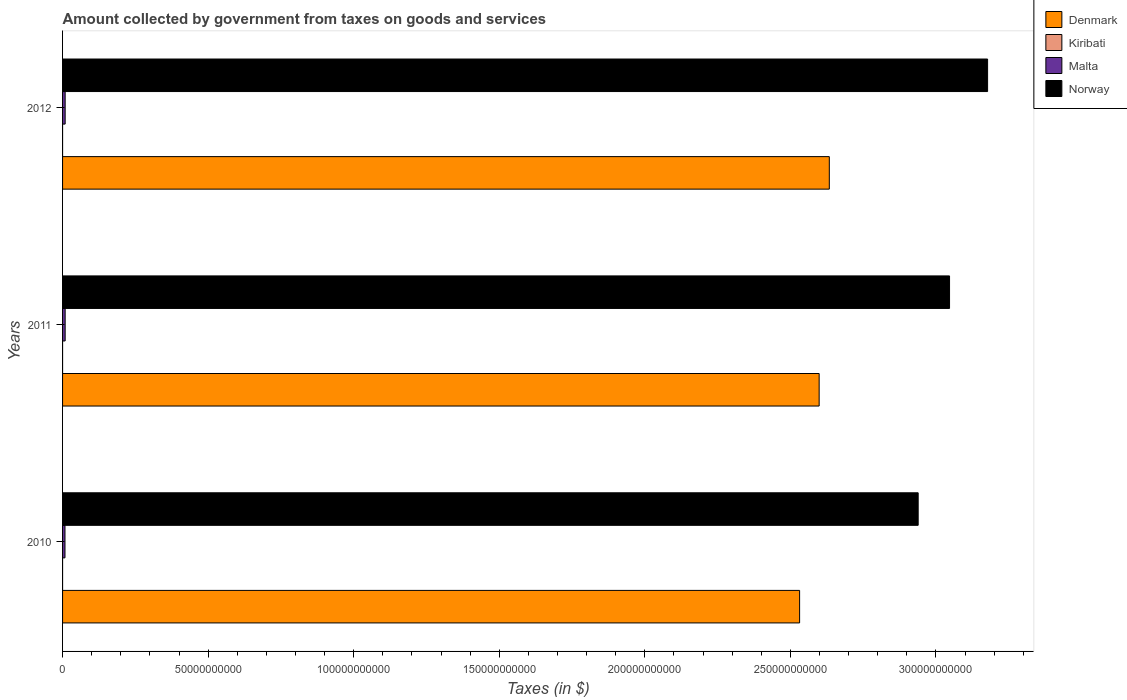Are the number of bars per tick equal to the number of legend labels?
Offer a terse response. Yes. Are the number of bars on each tick of the Y-axis equal?
Provide a succinct answer. Yes. How many bars are there on the 1st tick from the bottom?
Your answer should be very brief. 4. What is the label of the 3rd group of bars from the top?
Keep it short and to the point. 2010. What is the amount collected by government from taxes on goods and services in Kiribati in 2012?
Offer a very short reply. 7.29e+04. Across all years, what is the maximum amount collected by government from taxes on goods and services in Denmark?
Ensure brevity in your answer.  2.63e+11. Across all years, what is the minimum amount collected by government from taxes on goods and services in Kiribati?
Your answer should be compact. 7.29e+04. What is the total amount collected by government from taxes on goods and services in Denmark in the graph?
Give a very brief answer. 7.76e+11. What is the difference between the amount collected by government from taxes on goods and services in Malta in 2010 and that in 2011?
Offer a very short reply. -6.32e+07. What is the difference between the amount collected by government from taxes on goods and services in Malta in 2011 and the amount collected by government from taxes on goods and services in Norway in 2012?
Provide a short and direct response. -3.17e+11. What is the average amount collected by government from taxes on goods and services in Denmark per year?
Keep it short and to the point. 2.59e+11. In the year 2010, what is the difference between the amount collected by government from taxes on goods and services in Denmark and amount collected by government from taxes on goods and services in Kiribati?
Your answer should be very brief. 2.53e+11. In how many years, is the amount collected by government from taxes on goods and services in Kiribati greater than 260000000000 $?
Keep it short and to the point. 0. What is the ratio of the amount collected by government from taxes on goods and services in Malta in 2011 to that in 2012?
Your response must be concise. 1. Is the difference between the amount collected by government from taxes on goods and services in Denmark in 2011 and 2012 greater than the difference between the amount collected by government from taxes on goods and services in Kiribati in 2011 and 2012?
Keep it short and to the point. No. What is the difference between the highest and the second highest amount collected by government from taxes on goods and services in Kiribati?
Offer a very short reply. 1.47e+05. What is the difference between the highest and the lowest amount collected by government from taxes on goods and services in Malta?
Ensure brevity in your answer.  6.33e+07. Is it the case that in every year, the sum of the amount collected by government from taxes on goods and services in Denmark and amount collected by government from taxes on goods and services in Norway is greater than the sum of amount collected by government from taxes on goods and services in Kiribati and amount collected by government from taxes on goods and services in Malta?
Your answer should be very brief. Yes. What does the 2nd bar from the bottom in 2010 represents?
Provide a short and direct response. Kiribati. How many bars are there?
Offer a very short reply. 12. How many years are there in the graph?
Offer a very short reply. 3. What is the difference between two consecutive major ticks on the X-axis?
Provide a short and direct response. 5.00e+1. Are the values on the major ticks of X-axis written in scientific E-notation?
Offer a terse response. No. Does the graph contain any zero values?
Offer a very short reply. No. Does the graph contain grids?
Keep it short and to the point. No. Where does the legend appear in the graph?
Keep it short and to the point. Top right. What is the title of the graph?
Your answer should be very brief. Amount collected by government from taxes on goods and services. Does "Burundi" appear as one of the legend labels in the graph?
Provide a succinct answer. No. What is the label or title of the X-axis?
Make the answer very short. Taxes (in $). What is the label or title of the Y-axis?
Provide a short and direct response. Years. What is the Taxes (in $) in Denmark in 2010?
Keep it short and to the point. 2.53e+11. What is the Taxes (in $) in Kiribati in 2010?
Ensure brevity in your answer.  2.22e+05. What is the Taxes (in $) in Malta in 2010?
Your answer should be very brief. 8.29e+08. What is the Taxes (in $) in Norway in 2010?
Your answer should be very brief. 2.94e+11. What is the Taxes (in $) of Denmark in 2011?
Keep it short and to the point. 2.60e+11. What is the Taxes (in $) of Kiribati in 2011?
Make the answer very short. 7.46e+04. What is the Taxes (in $) of Malta in 2011?
Provide a short and direct response. 8.92e+08. What is the Taxes (in $) in Norway in 2011?
Your answer should be very brief. 3.05e+11. What is the Taxes (in $) of Denmark in 2012?
Your answer should be very brief. 2.63e+11. What is the Taxes (in $) in Kiribati in 2012?
Ensure brevity in your answer.  7.29e+04. What is the Taxes (in $) of Malta in 2012?
Your answer should be very brief. 8.92e+08. What is the Taxes (in $) in Norway in 2012?
Offer a very short reply. 3.18e+11. Across all years, what is the maximum Taxes (in $) in Denmark?
Give a very brief answer. 2.63e+11. Across all years, what is the maximum Taxes (in $) of Kiribati?
Keep it short and to the point. 2.22e+05. Across all years, what is the maximum Taxes (in $) in Malta?
Make the answer very short. 8.92e+08. Across all years, what is the maximum Taxes (in $) of Norway?
Your response must be concise. 3.18e+11. Across all years, what is the minimum Taxes (in $) of Denmark?
Your response must be concise. 2.53e+11. Across all years, what is the minimum Taxes (in $) in Kiribati?
Your response must be concise. 7.29e+04. Across all years, what is the minimum Taxes (in $) of Malta?
Give a very brief answer. 8.29e+08. Across all years, what is the minimum Taxes (in $) of Norway?
Make the answer very short. 2.94e+11. What is the total Taxes (in $) in Denmark in the graph?
Your response must be concise. 7.76e+11. What is the total Taxes (in $) in Kiribati in the graph?
Ensure brevity in your answer.  3.69e+05. What is the total Taxes (in $) of Malta in the graph?
Provide a succinct answer. 2.61e+09. What is the total Taxes (in $) in Norway in the graph?
Give a very brief answer. 9.16e+11. What is the difference between the Taxes (in $) in Denmark in 2010 and that in 2011?
Provide a succinct answer. -6.71e+09. What is the difference between the Taxes (in $) of Kiribati in 2010 and that in 2011?
Provide a short and direct response. 1.47e+05. What is the difference between the Taxes (in $) in Malta in 2010 and that in 2011?
Offer a terse response. -6.32e+07. What is the difference between the Taxes (in $) in Norway in 2010 and that in 2011?
Offer a terse response. -1.08e+1. What is the difference between the Taxes (in $) of Denmark in 2010 and that in 2012?
Your response must be concise. -1.02e+1. What is the difference between the Taxes (in $) in Kiribati in 2010 and that in 2012?
Your answer should be compact. 1.49e+05. What is the difference between the Taxes (in $) in Malta in 2010 and that in 2012?
Make the answer very short. -6.33e+07. What is the difference between the Taxes (in $) in Norway in 2010 and that in 2012?
Provide a short and direct response. -2.38e+1. What is the difference between the Taxes (in $) of Denmark in 2011 and that in 2012?
Ensure brevity in your answer.  -3.49e+09. What is the difference between the Taxes (in $) of Kiribati in 2011 and that in 2012?
Provide a short and direct response. 1687.54. What is the difference between the Taxes (in $) of Malta in 2011 and that in 2012?
Provide a succinct answer. -1.06e+05. What is the difference between the Taxes (in $) in Norway in 2011 and that in 2012?
Keep it short and to the point. -1.31e+1. What is the difference between the Taxes (in $) in Denmark in 2010 and the Taxes (in $) in Kiribati in 2011?
Give a very brief answer. 2.53e+11. What is the difference between the Taxes (in $) in Denmark in 2010 and the Taxes (in $) in Malta in 2011?
Give a very brief answer. 2.52e+11. What is the difference between the Taxes (in $) in Denmark in 2010 and the Taxes (in $) in Norway in 2011?
Provide a short and direct response. -5.15e+1. What is the difference between the Taxes (in $) in Kiribati in 2010 and the Taxes (in $) in Malta in 2011?
Make the answer very short. -8.92e+08. What is the difference between the Taxes (in $) of Kiribati in 2010 and the Taxes (in $) of Norway in 2011?
Your answer should be compact. -3.05e+11. What is the difference between the Taxes (in $) of Malta in 2010 and the Taxes (in $) of Norway in 2011?
Your answer should be very brief. -3.04e+11. What is the difference between the Taxes (in $) in Denmark in 2010 and the Taxes (in $) in Kiribati in 2012?
Your response must be concise. 2.53e+11. What is the difference between the Taxes (in $) in Denmark in 2010 and the Taxes (in $) in Malta in 2012?
Your response must be concise. 2.52e+11. What is the difference between the Taxes (in $) in Denmark in 2010 and the Taxes (in $) in Norway in 2012?
Your answer should be very brief. -6.46e+1. What is the difference between the Taxes (in $) of Kiribati in 2010 and the Taxes (in $) of Malta in 2012?
Offer a very short reply. -8.92e+08. What is the difference between the Taxes (in $) of Kiribati in 2010 and the Taxes (in $) of Norway in 2012?
Give a very brief answer. -3.18e+11. What is the difference between the Taxes (in $) of Malta in 2010 and the Taxes (in $) of Norway in 2012?
Your answer should be very brief. -3.17e+11. What is the difference between the Taxes (in $) in Denmark in 2011 and the Taxes (in $) in Kiribati in 2012?
Give a very brief answer. 2.60e+11. What is the difference between the Taxes (in $) in Denmark in 2011 and the Taxes (in $) in Malta in 2012?
Your answer should be very brief. 2.59e+11. What is the difference between the Taxes (in $) of Denmark in 2011 and the Taxes (in $) of Norway in 2012?
Ensure brevity in your answer.  -5.79e+1. What is the difference between the Taxes (in $) of Kiribati in 2011 and the Taxes (in $) of Malta in 2012?
Provide a short and direct response. -8.92e+08. What is the difference between the Taxes (in $) in Kiribati in 2011 and the Taxes (in $) in Norway in 2012?
Your answer should be compact. -3.18e+11. What is the difference between the Taxes (in $) of Malta in 2011 and the Taxes (in $) of Norway in 2012?
Offer a terse response. -3.17e+11. What is the average Taxes (in $) of Denmark per year?
Your response must be concise. 2.59e+11. What is the average Taxes (in $) in Kiribati per year?
Offer a very short reply. 1.23e+05. What is the average Taxes (in $) of Malta per year?
Offer a very short reply. 8.71e+08. What is the average Taxes (in $) in Norway per year?
Give a very brief answer. 3.05e+11. In the year 2010, what is the difference between the Taxes (in $) of Denmark and Taxes (in $) of Kiribati?
Provide a short and direct response. 2.53e+11. In the year 2010, what is the difference between the Taxes (in $) of Denmark and Taxes (in $) of Malta?
Provide a succinct answer. 2.52e+11. In the year 2010, what is the difference between the Taxes (in $) of Denmark and Taxes (in $) of Norway?
Give a very brief answer. -4.07e+1. In the year 2010, what is the difference between the Taxes (in $) of Kiribati and Taxes (in $) of Malta?
Ensure brevity in your answer.  -8.29e+08. In the year 2010, what is the difference between the Taxes (in $) in Kiribati and Taxes (in $) in Norway?
Provide a succinct answer. -2.94e+11. In the year 2010, what is the difference between the Taxes (in $) in Malta and Taxes (in $) in Norway?
Offer a terse response. -2.93e+11. In the year 2011, what is the difference between the Taxes (in $) of Denmark and Taxes (in $) of Kiribati?
Provide a succinct answer. 2.60e+11. In the year 2011, what is the difference between the Taxes (in $) in Denmark and Taxes (in $) in Malta?
Offer a very short reply. 2.59e+11. In the year 2011, what is the difference between the Taxes (in $) in Denmark and Taxes (in $) in Norway?
Make the answer very short. -4.48e+1. In the year 2011, what is the difference between the Taxes (in $) of Kiribati and Taxes (in $) of Malta?
Ensure brevity in your answer.  -8.92e+08. In the year 2011, what is the difference between the Taxes (in $) of Kiribati and Taxes (in $) of Norway?
Offer a terse response. -3.05e+11. In the year 2011, what is the difference between the Taxes (in $) in Malta and Taxes (in $) in Norway?
Offer a very short reply. -3.04e+11. In the year 2012, what is the difference between the Taxes (in $) of Denmark and Taxes (in $) of Kiribati?
Keep it short and to the point. 2.63e+11. In the year 2012, what is the difference between the Taxes (in $) of Denmark and Taxes (in $) of Malta?
Keep it short and to the point. 2.62e+11. In the year 2012, what is the difference between the Taxes (in $) in Denmark and Taxes (in $) in Norway?
Offer a terse response. -5.44e+1. In the year 2012, what is the difference between the Taxes (in $) of Kiribati and Taxes (in $) of Malta?
Your response must be concise. -8.92e+08. In the year 2012, what is the difference between the Taxes (in $) of Kiribati and Taxes (in $) of Norway?
Your answer should be compact. -3.18e+11. In the year 2012, what is the difference between the Taxes (in $) in Malta and Taxes (in $) in Norway?
Provide a short and direct response. -3.17e+11. What is the ratio of the Taxes (in $) of Denmark in 2010 to that in 2011?
Ensure brevity in your answer.  0.97. What is the ratio of the Taxes (in $) in Kiribati in 2010 to that in 2011?
Your answer should be very brief. 2.97. What is the ratio of the Taxes (in $) of Malta in 2010 to that in 2011?
Your answer should be compact. 0.93. What is the ratio of the Taxes (in $) in Norway in 2010 to that in 2011?
Give a very brief answer. 0.96. What is the ratio of the Taxes (in $) in Denmark in 2010 to that in 2012?
Your response must be concise. 0.96. What is the ratio of the Taxes (in $) of Kiribati in 2010 to that in 2012?
Make the answer very short. 3.04. What is the ratio of the Taxes (in $) in Malta in 2010 to that in 2012?
Provide a succinct answer. 0.93. What is the ratio of the Taxes (in $) in Norway in 2010 to that in 2012?
Make the answer very short. 0.92. What is the ratio of the Taxes (in $) in Denmark in 2011 to that in 2012?
Give a very brief answer. 0.99. What is the ratio of the Taxes (in $) of Kiribati in 2011 to that in 2012?
Provide a short and direct response. 1.02. What is the ratio of the Taxes (in $) of Norway in 2011 to that in 2012?
Give a very brief answer. 0.96. What is the difference between the highest and the second highest Taxes (in $) of Denmark?
Give a very brief answer. 3.49e+09. What is the difference between the highest and the second highest Taxes (in $) in Kiribati?
Your answer should be very brief. 1.47e+05. What is the difference between the highest and the second highest Taxes (in $) in Malta?
Ensure brevity in your answer.  1.06e+05. What is the difference between the highest and the second highest Taxes (in $) in Norway?
Keep it short and to the point. 1.31e+1. What is the difference between the highest and the lowest Taxes (in $) in Denmark?
Offer a terse response. 1.02e+1. What is the difference between the highest and the lowest Taxes (in $) in Kiribati?
Keep it short and to the point. 1.49e+05. What is the difference between the highest and the lowest Taxes (in $) of Malta?
Provide a succinct answer. 6.33e+07. What is the difference between the highest and the lowest Taxes (in $) of Norway?
Ensure brevity in your answer.  2.38e+1. 